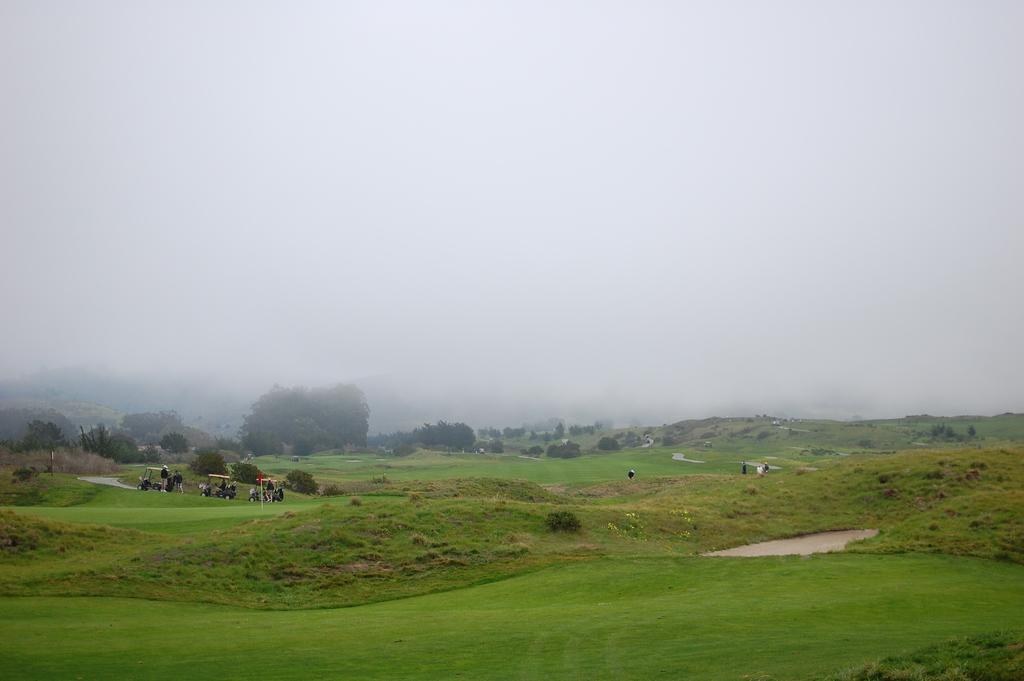What type of vegetation is present in the image? There is grass, trees, and plants in the image. Who or what else can be seen in the image? There are people in the image. Can you describe the objects on the left side of the image? Unfortunately, the facts provided do not specify the objects on the left side of the image. What is visible at the top of the image? The sky is visible at the top of the image. What type of harbor can be seen in the image? There is no harbor present in the image. What is the topic of the discussion taking place among the people in the image? The facts provided do not mention any discussion among the people in the image. 